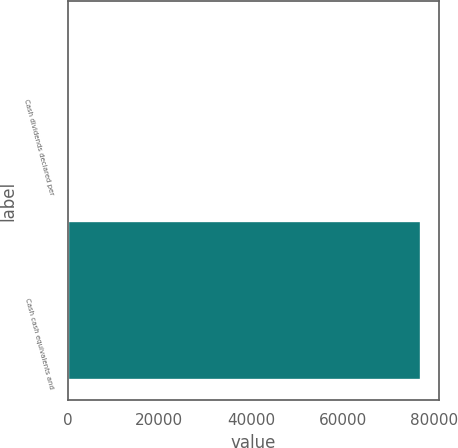<chart> <loc_0><loc_0><loc_500><loc_500><bar_chart><fcel>Cash dividends declared per<fcel>Cash cash equivalents and<nl><fcel>0.92<fcel>77022<nl></chart> 